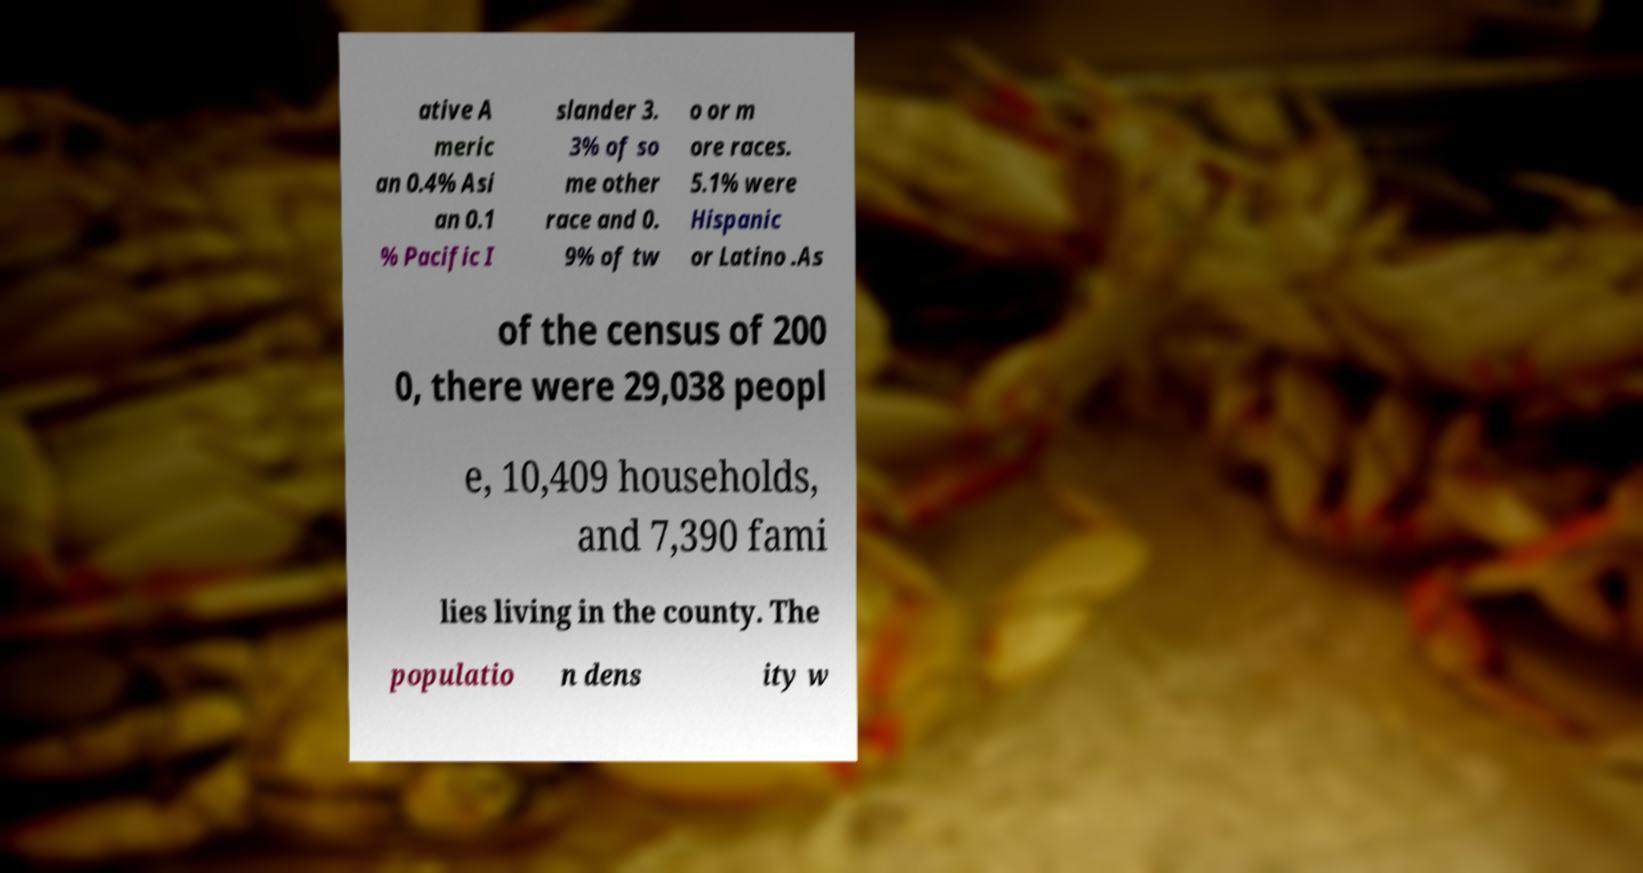There's text embedded in this image that I need extracted. Can you transcribe it verbatim? ative A meric an 0.4% Asi an 0.1 % Pacific I slander 3. 3% of so me other race and 0. 9% of tw o or m ore races. 5.1% were Hispanic or Latino .As of the census of 200 0, there were 29,038 peopl e, 10,409 households, and 7,390 fami lies living in the county. The populatio n dens ity w 